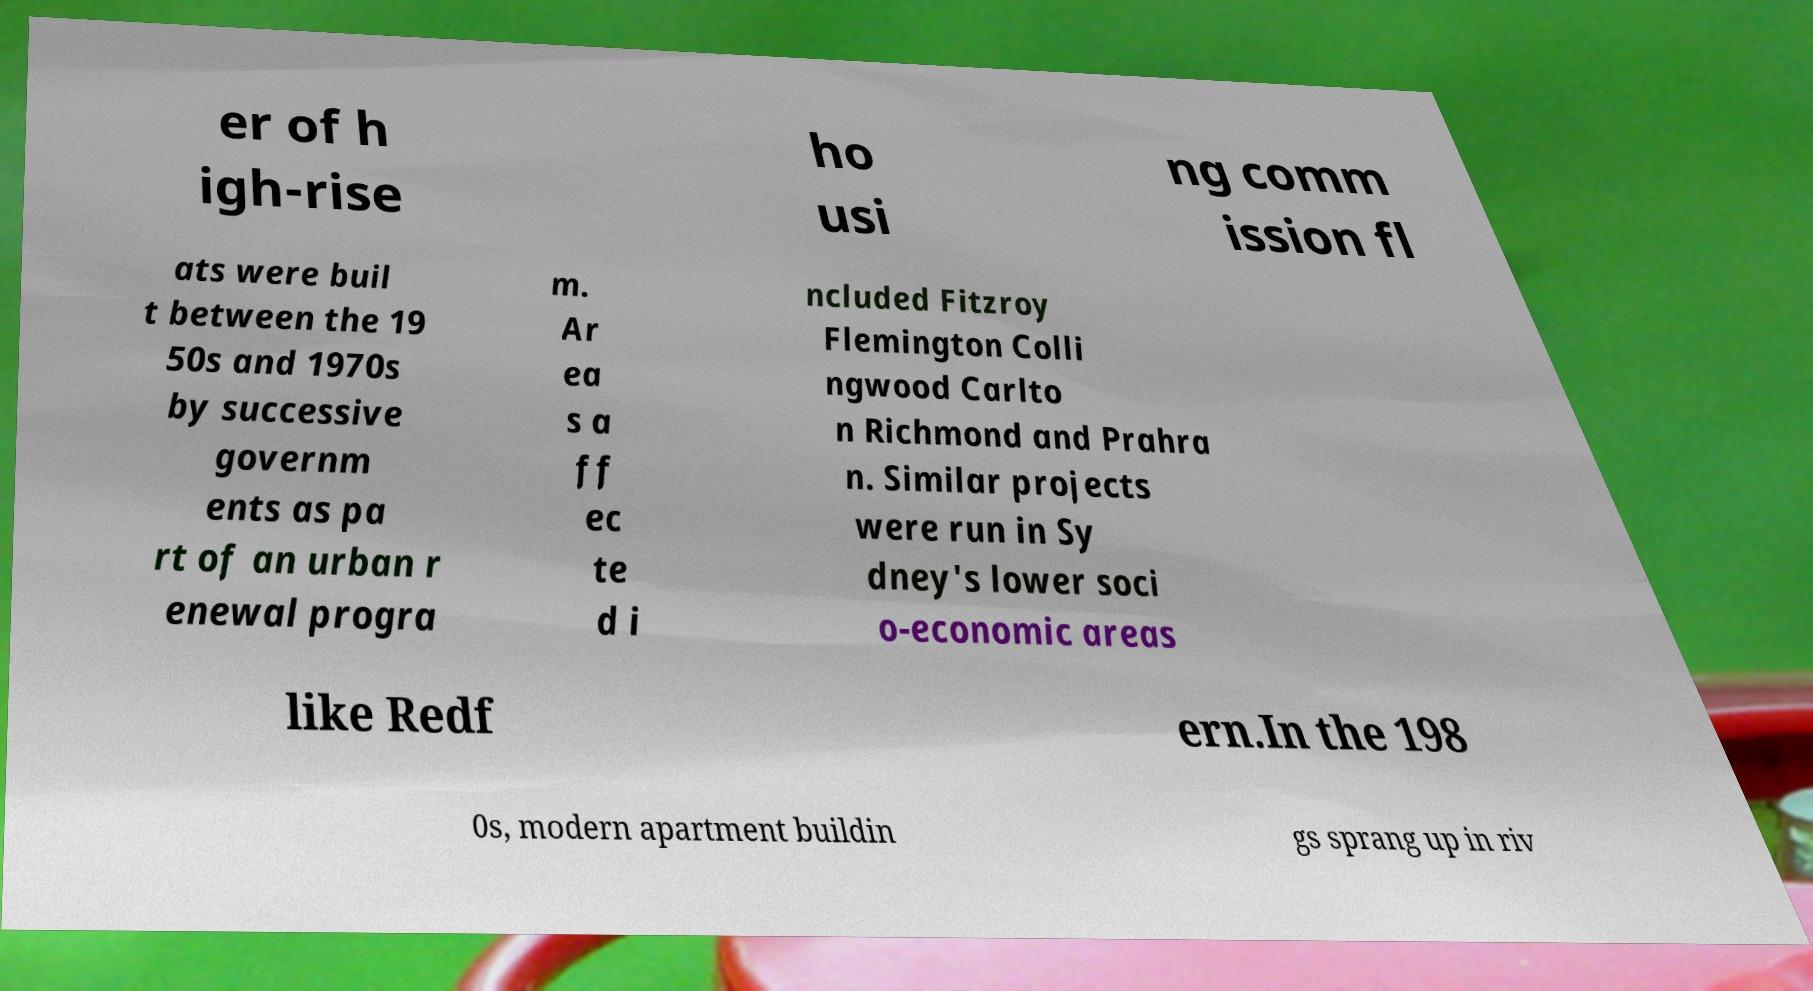Can you accurately transcribe the text from the provided image for me? er of h igh-rise ho usi ng comm ission fl ats were buil t between the 19 50s and 1970s by successive governm ents as pa rt of an urban r enewal progra m. Ar ea s a ff ec te d i ncluded Fitzroy Flemington Colli ngwood Carlto n Richmond and Prahra n. Similar projects were run in Sy dney's lower soci o-economic areas like Redf ern.In the 198 0s, modern apartment buildin gs sprang up in riv 